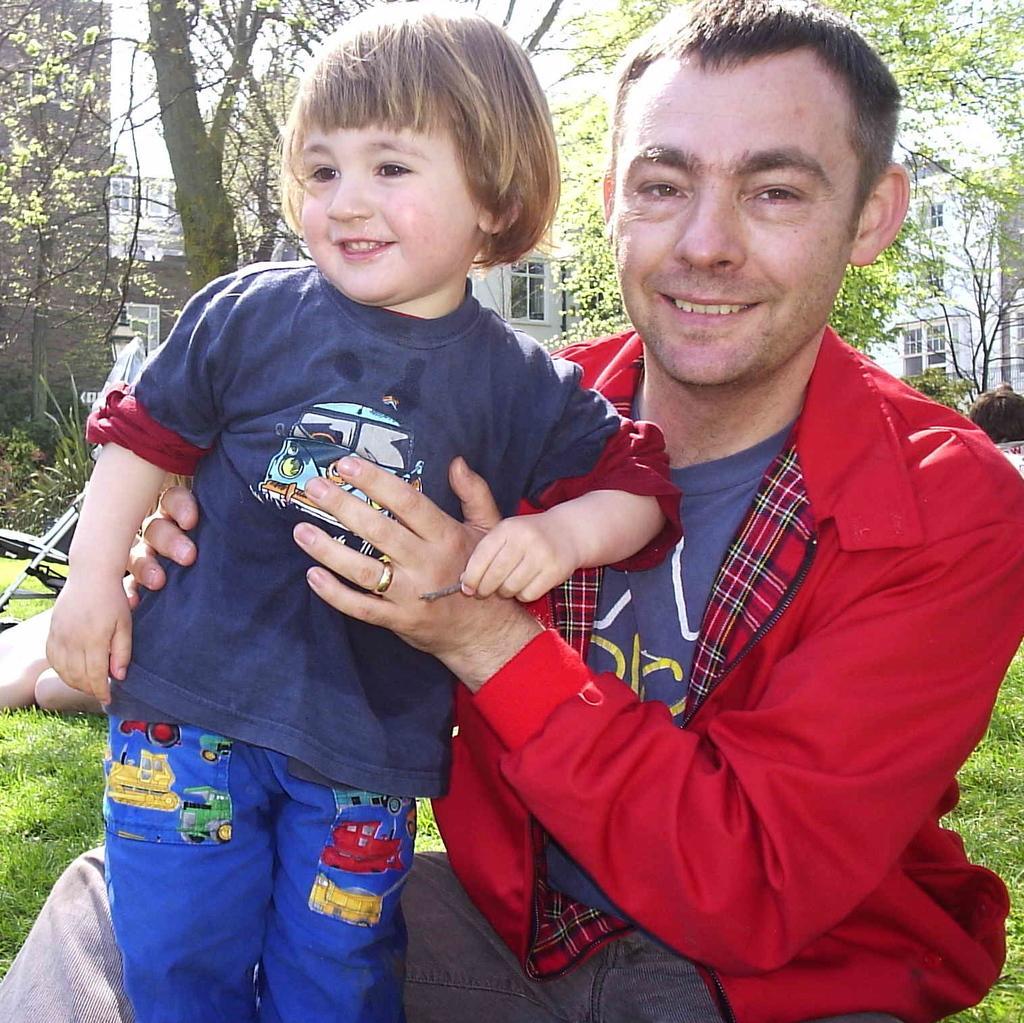Could you give a brief overview of what you see in this image? In this picture there is a man and a small girl in the center of the image, on the grassland and there is another man behind him, there are trees and buildings in the background area of the image. 